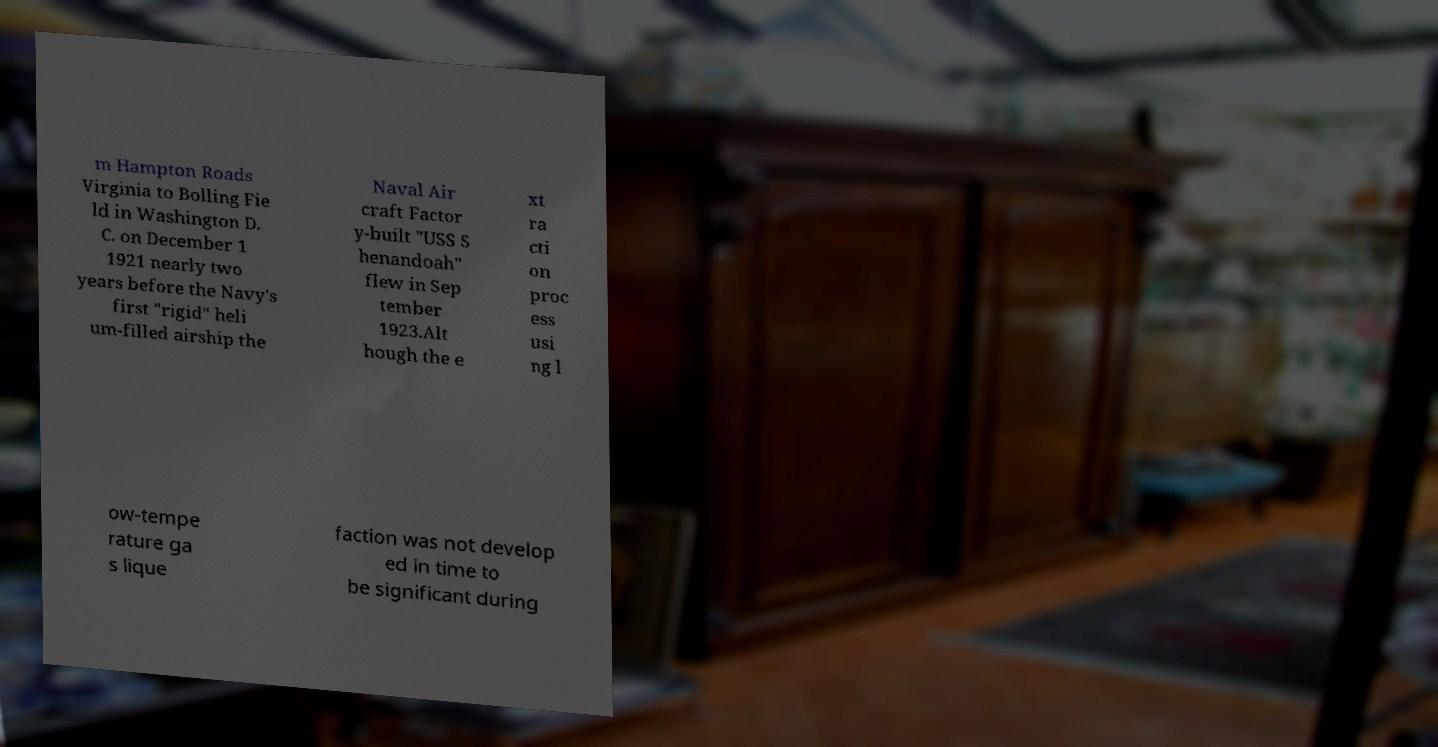Can you accurately transcribe the text from the provided image for me? m Hampton Roads Virginia to Bolling Fie ld in Washington D. C. on December 1 1921 nearly two years before the Navy's first "rigid" heli um-filled airship the Naval Air craft Factor y-built "USS S henandoah" flew in Sep tember 1923.Alt hough the e xt ra cti on proc ess usi ng l ow-tempe rature ga s lique faction was not develop ed in time to be significant during 